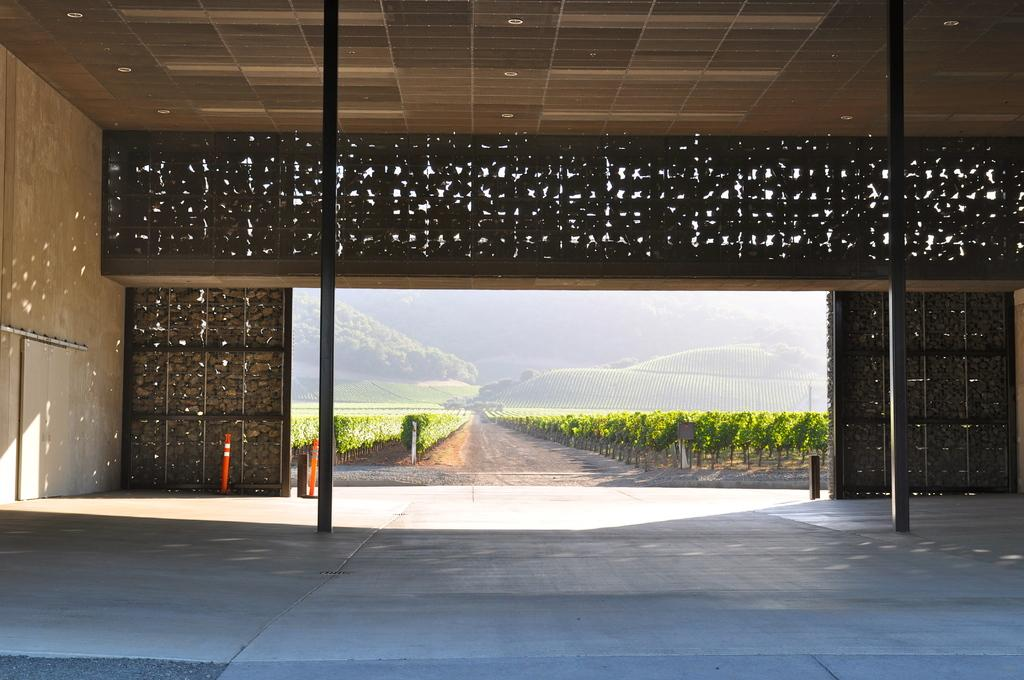What material is used for the roof in the image? The roof in the image is made of wood. What can be seen on the ground in the image? There is a road visible in the image. Where are the trees located in the image? There are many trees on the left side of the image. What type of stocking is hanging from the roof in the image? There is no stocking hanging from the roof in the image; the roof is made of wood. 